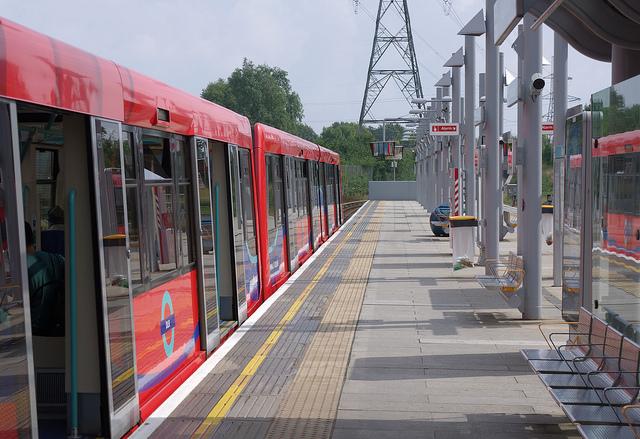What color is the train?
Be succinct. Red. Is there a gap to "mind" between the train and the platform?
Write a very short answer. No. Are there any people boarding the train?
Answer briefly. No. Is anyone stepping into the train?
Be succinct. No. 